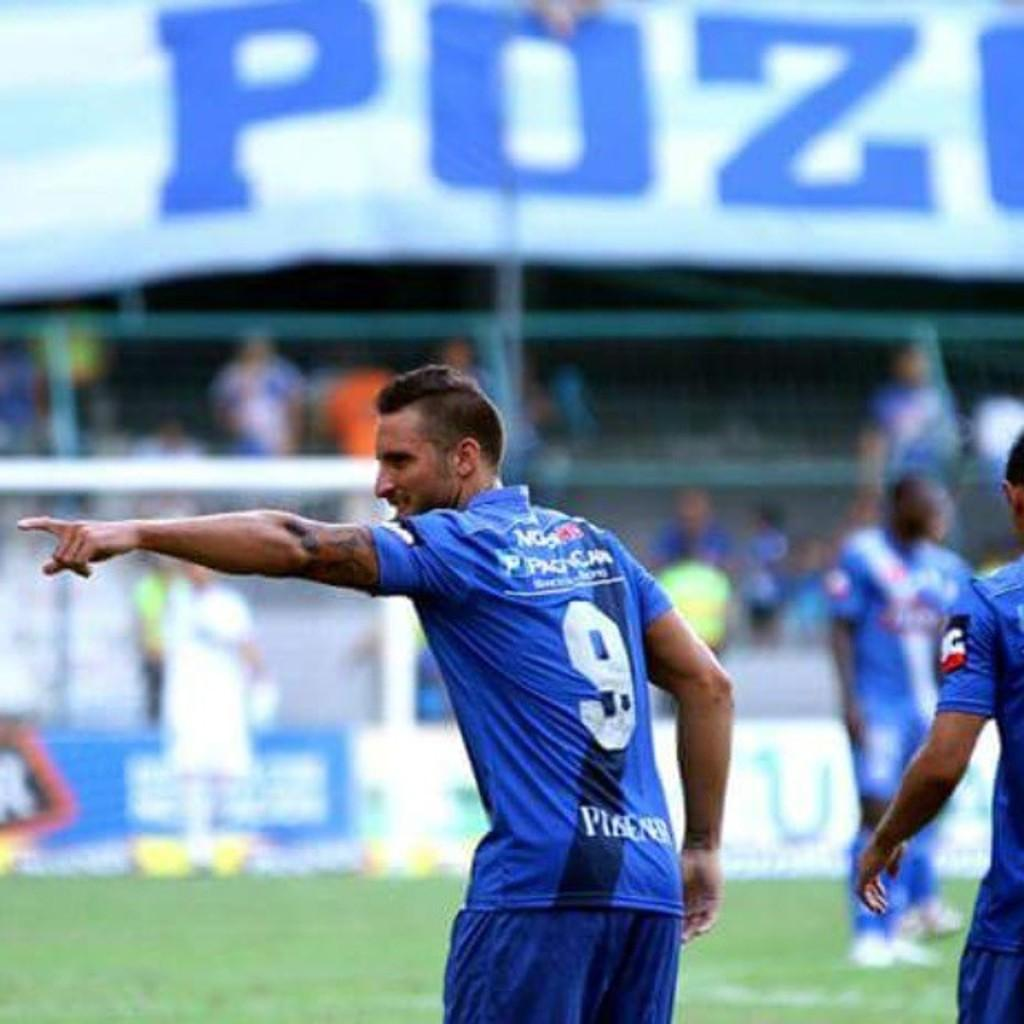<image>
Render a clear and concise summary of the photo. Soccer player wearing the number 9 pointing at something. 